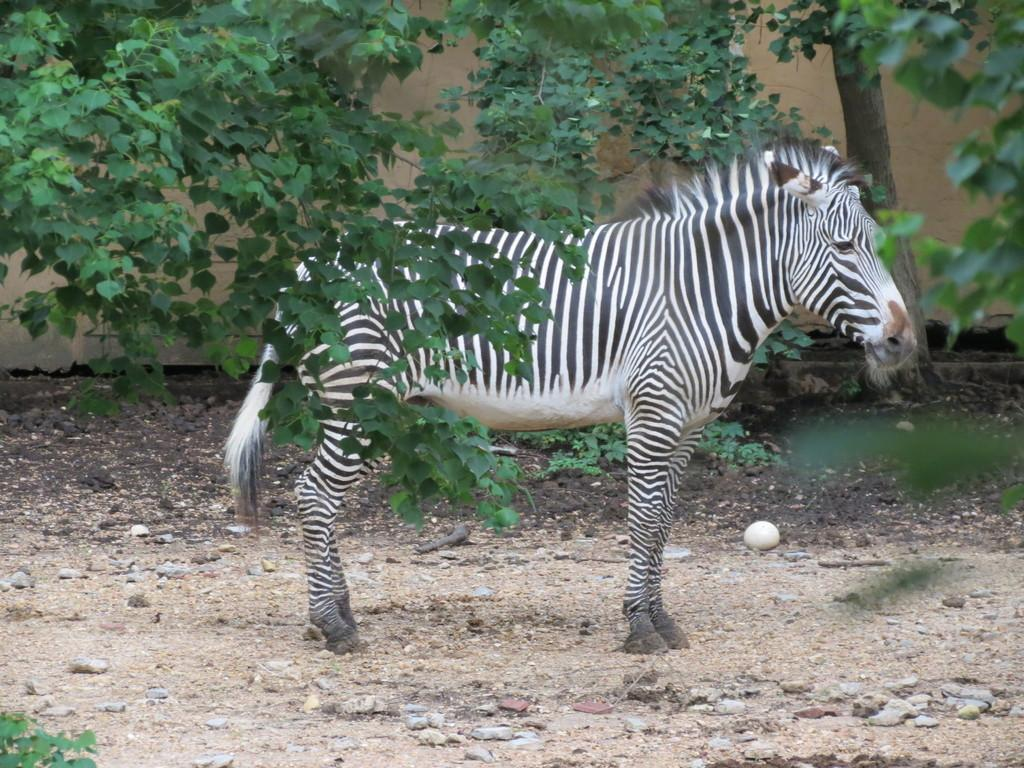What type of animal is on the ground in the image? The image features an animal on the ground, but the specific type of animal is not mentioned in the provided facts. What can be seen in the background of the image? There are trees visible in the image. What structure is present in the image? There is a wall in the image. How many feet are visible in the image? There is no mention of feet in the provided facts, so it is impossible to determine how many feet are visible in the image. What type of tramp is shown in the image? There is no tramp present in the image; it features an animal on the ground, trees, and a wall. 